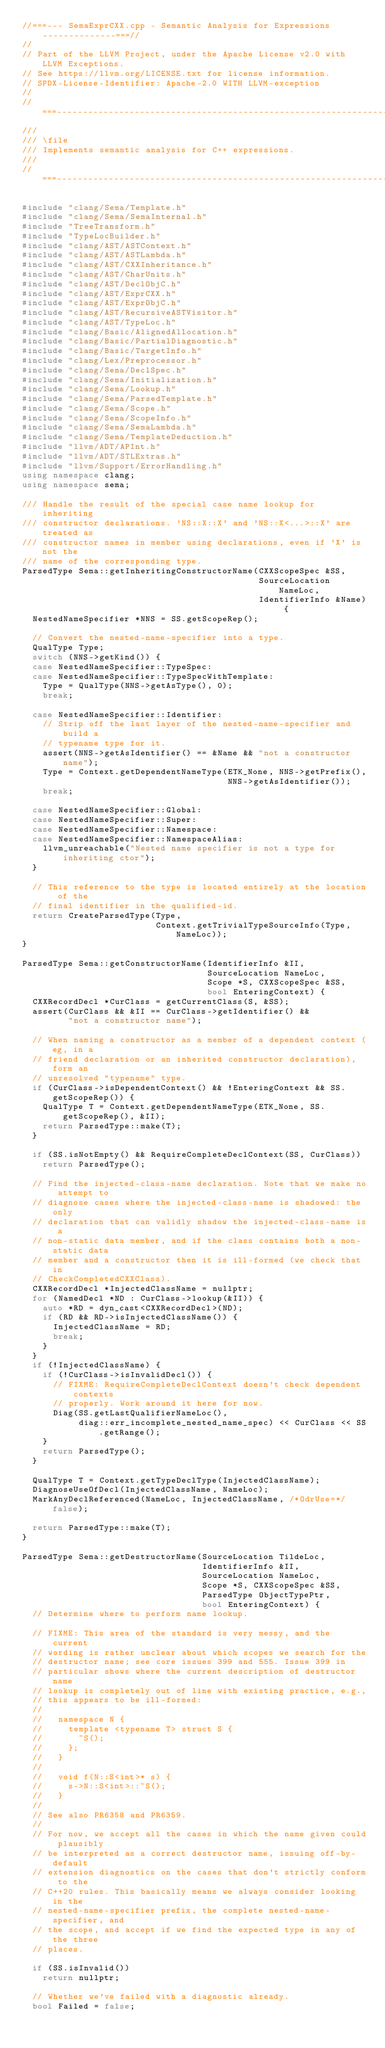Convert code to text. <code><loc_0><loc_0><loc_500><loc_500><_C++_>//===--- SemaExprCXX.cpp - Semantic Analysis for Expressions --------------===//
//
// Part of the LLVM Project, under the Apache License v2.0 with LLVM Exceptions.
// See https://llvm.org/LICENSE.txt for license information.
// SPDX-License-Identifier: Apache-2.0 WITH LLVM-exception
//
//===----------------------------------------------------------------------===//
///
/// \file
/// Implements semantic analysis for C++ expressions.
///
//===----------------------------------------------------------------------===//

#include "clang/Sema/Template.h"
#include "clang/Sema/SemaInternal.h"
#include "TreeTransform.h"
#include "TypeLocBuilder.h"
#include "clang/AST/ASTContext.h"
#include "clang/AST/ASTLambda.h"
#include "clang/AST/CXXInheritance.h"
#include "clang/AST/CharUnits.h"
#include "clang/AST/DeclObjC.h"
#include "clang/AST/ExprCXX.h"
#include "clang/AST/ExprObjC.h"
#include "clang/AST/RecursiveASTVisitor.h"
#include "clang/AST/TypeLoc.h"
#include "clang/Basic/AlignedAllocation.h"
#include "clang/Basic/PartialDiagnostic.h"
#include "clang/Basic/TargetInfo.h"
#include "clang/Lex/Preprocessor.h"
#include "clang/Sema/DeclSpec.h"
#include "clang/Sema/Initialization.h"
#include "clang/Sema/Lookup.h"
#include "clang/Sema/ParsedTemplate.h"
#include "clang/Sema/Scope.h"
#include "clang/Sema/ScopeInfo.h"
#include "clang/Sema/SemaLambda.h"
#include "clang/Sema/TemplateDeduction.h"
#include "llvm/ADT/APInt.h"
#include "llvm/ADT/STLExtras.h"
#include "llvm/Support/ErrorHandling.h"
using namespace clang;
using namespace sema;

/// Handle the result of the special case name lookup for inheriting
/// constructor declarations. 'NS::X::X' and 'NS::X<...>::X' are treated as
/// constructor names in member using declarations, even if 'X' is not the
/// name of the corresponding type.
ParsedType Sema::getInheritingConstructorName(CXXScopeSpec &SS,
                                              SourceLocation NameLoc,
                                              IdentifierInfo &Name) {
  NestedNameSpecifier *NNS = SS.getScopeRep();

  // Convert the nested-name-specifier into a type.
  QualType Type;
  switch (NNS->getKind()) {
  case NestedNameSpecifier::TypeSpec:
  case NestedNameSpecifier::TypeSpecWithTemplate:
    Type = QualType(NNS->getAsType(), 0);
    break;

  case NestedNameSpecifier::Identifier:
    // Strip off the last layer of the nested-name-specifier and build a
    // typename type for it.
    assert(NNS->getAsIdentifier() == &Name && "not a constructor name");
    Type = Context.getDependentNameType(ETK_None, NNS->getPrefix(),
                                        NNS->getAsIdentifier());
    break;

  case NestedNameSpecifier::Global:
  case NestedNameSpecifier::Super:
  case NestedNameSpecifier::Namespace:
  case NestedNameSpecifier::NamespaceAlias:
    llvm_unreachable("Nested name specifier is not a type for inheriting ctor");
  }

  // This reference to the type is located entirely at the location of the
  // final identifier in the qualified-id.
  return CreateParsedType(Type,
                          Context.getTrivialTypeSourceInfo(Type, NameLoc));
}

ParsedType Sema::getConstructorName(IdentifierInfo &II,
                                    SourceLocation NameLoc,
                                    Scope *S, CXXScopeSpec &SS,
                                    bool EnteringContext) {
  CXXRecordDecl *CurClass = getCurrentClass(S, &SS);
  assert(CurClass && &II == CurClass->getIdentifier() &&
         "not a constructor name");

  // When naming a constructor as a member of a dependent context (eg, in a
  // friend declaration or an inherited constructor declaration), form an
  // unresolved "typename" type.
  if (CurClass->isDependentContext() && !EnteringContext && SS.getScopeRep()) {
    QualType T = Context.getDependentNameType(ETK_None, SS.getScopeRep(), &II);
    return ParsedType::make(T);
  }

  if (SS.isNotEmpty() && RequireCompleteDeclContext(SS, CurClass))
    return ParsedType();

  // Find the injected-class-name declaration. Note that we make no attempt to
  // diagnose cases where the injected-class-name is shadowed: the only
  // declaration that can validly shadow the injected-class-name is a
  // non-static data member, and if the class contains both a non-static data
  // member and a constructor then it is ill-formed (we check that in
  // CheckCompletedCXXClass).
  CXXRecordDecl *InjectedClassName = nullptr;
  for (NamedDecl *ND : CurClass->lookup(&II)) {
    auto *RD = dyn_cast<CXXRecordDecl>(ND);
    if (RD && RD->isInjectedClassName()) {
      InjectedClassName = RD;
      break;
    }
  }
  if (!InjectedClassName) {
    if (!CurClass->isInvalidDecl()) {
      // FIXME: RequireCompleteDeclContext doesn't check dependent contexts
      // properly. Work around it here for now.
      Diag(SS.getLastQualifierNameLoc(),
           diag::err_incomplete_nested_name_spec) << CurClass << SS.getRange();
    }
    return ParsedType();
  }

  QualType T = Context.getTypeDeclType(InjectedClassName);
  DiagnoseUseOfDecl(InjectedClassName, NameLoc);
  MarkAnyDeclReferenced(NameLoc, InjectedClassName, /*OdrUse=*/false);

  return ParsedType::make(T);
}

ParsedType Sema::getDestructorName(SourceLocation TildeLoc,
                                   IdentifierInfo &II,
                                   SourceLocation NameLoc,
                                   Scope *S, CXXScopeSpec &SS,
                                   ParsedType ObjectTypePtr,
                                   bool EnteringContext) {
  // Determine where to perform name lookup.

  // FIXME: This area of the standard is very messy, and the current
  // wording is rather unclear about which scopes we search for the
  // destructor name; see core issues 399 and 555. Issue 399 in
  // particular shows where the current description of destructor name
  // lookup is completely out of line with existing practice, e.g.,
  // this appears to be ill-formed:
  //
  //   namespace N {
  //     template <typename T> struct S {
  //       ~S();
  //     };
  //   }
  //
  //   void f(N::S<int>* s) {
  //     s->N::S<int>::~S();
  //   }
  //
  // See also PR6358 and PR6359.
  //
  // For now, we accept all the cases in which the name given could plausibly
  // be interpreted as a correct destructor name, issuing off-by-default
  // extension diagnostics on the cases that don't strictly conform to the
  // C++20 rules. This basically means we always consider looking in the
  // nested-name-specifier prefix, the complete nested-name-specifier, and
  // the scope, and accept if we find the expected type in any of the three
  // places.

  if (SS.isInvalid())
    return nullptr;

  // Whether we've failed with a diagnostic already.
  bool Failed = false;
</code> 